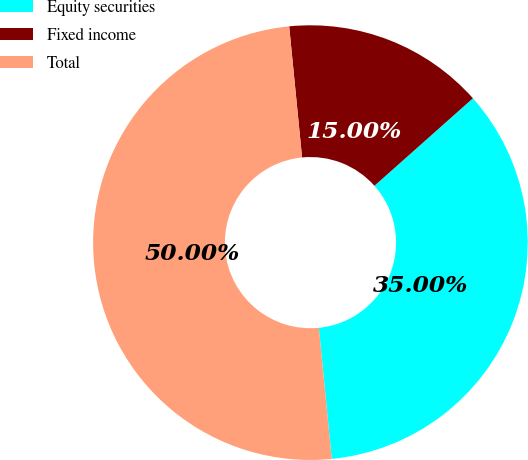<chart> <loc_0><loc_0><loc_500><loc_500><pie_chart><fcel>Equity securities<fcel>Fixed income<fcel>Total<nl><fcel>35.0%<fcel>15.0%<fcel>50.0%<nl></chart> 